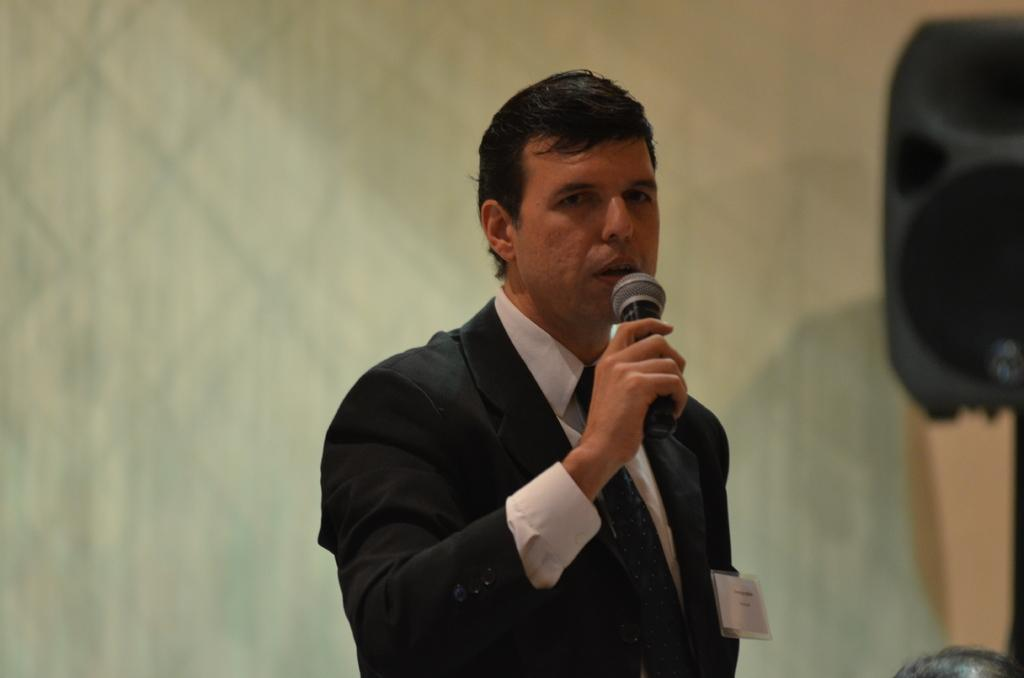What is the person in the image doing? The person is standing in the image and holding a microphone. What is the person wearing? The person is wearing a black suit. What can be seen in the background of the image? There is a wall in the background of the image. Can you see any kettles or sand in the image? No, there are no kettles or sand present in the image. How many boys are visible in the image? There is no mention of boys in the provided facts, so we cannot determine the number of boys in the image. 